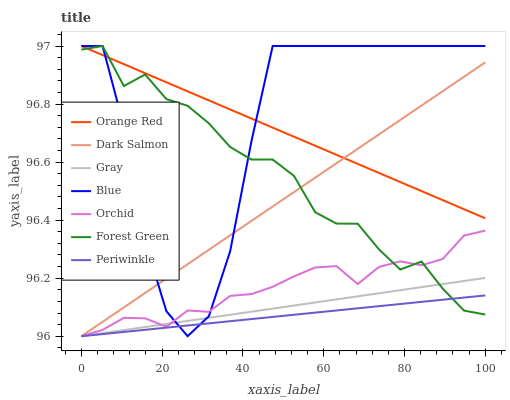Does Periwinkle have the minimum area under the curve?
Answer yes or no. Yes. Does Blue have the maximum area under the curve?
Answer yes or no. Yes. Does Gray have the minimum area under the curve?
Answer yes or no. No. Does Gray have the maximum area under the curve?
Answer yes or no. No. Is Gray the smoothest?
Answer yes or no. Yes. Is Blue the roughest?
Answer yes or no. Yes. Is Dark Salmon the smoothest?
Answer yes or no. No. Is Dark Salmon the roughest?
Answer yes or no. No. Does Gray have the lowest value?
Answer yes or no. Yes. Does Forest Green have the lowest value?
Answer yes or no. No. Does Orange Red have the highest value?
Answer yes or no. Yes. Does Gray have the highest value?
Answer yes or no. No. Is Gray less than Orange Red?
Answer yes or no. Yes. Is Orange Red greater than Orchid?
Answer yes or no. Yes. Does Gray intersect Forest Green?
Answer yes or no. Yes. Is Gray less than Forest Green?
Answer yes or no. No. Is Gray greater than Forest Green?
Answer yes or no. No. Does Gray intersect Orange Red?
Answer yes or no. No. 